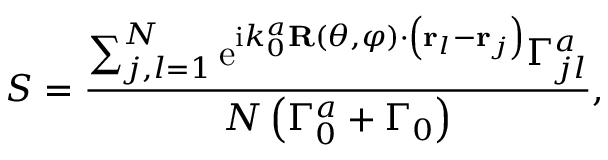<formula> <loc_0><loc_0><loc_500><loc_500>S = \frac { \sum _ { j , l = 1 } ^ { N } e ^ { i k _ { 0 } ^ { a } R ( \theta , \varphi ) \cdot \left ( { r } _ { l } - { r } _ { j } \right ) } \Gamma _ { j l } ^ { a } } { N \left ( \Gamma _ { 0 } ^ { a } + \Gamma _ { 0 } \right ) } ,</formula> 